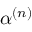<formula> <loc_0><loc_0><loc_500><loc_500>\alpha ^ { ( n ) }</formula> 